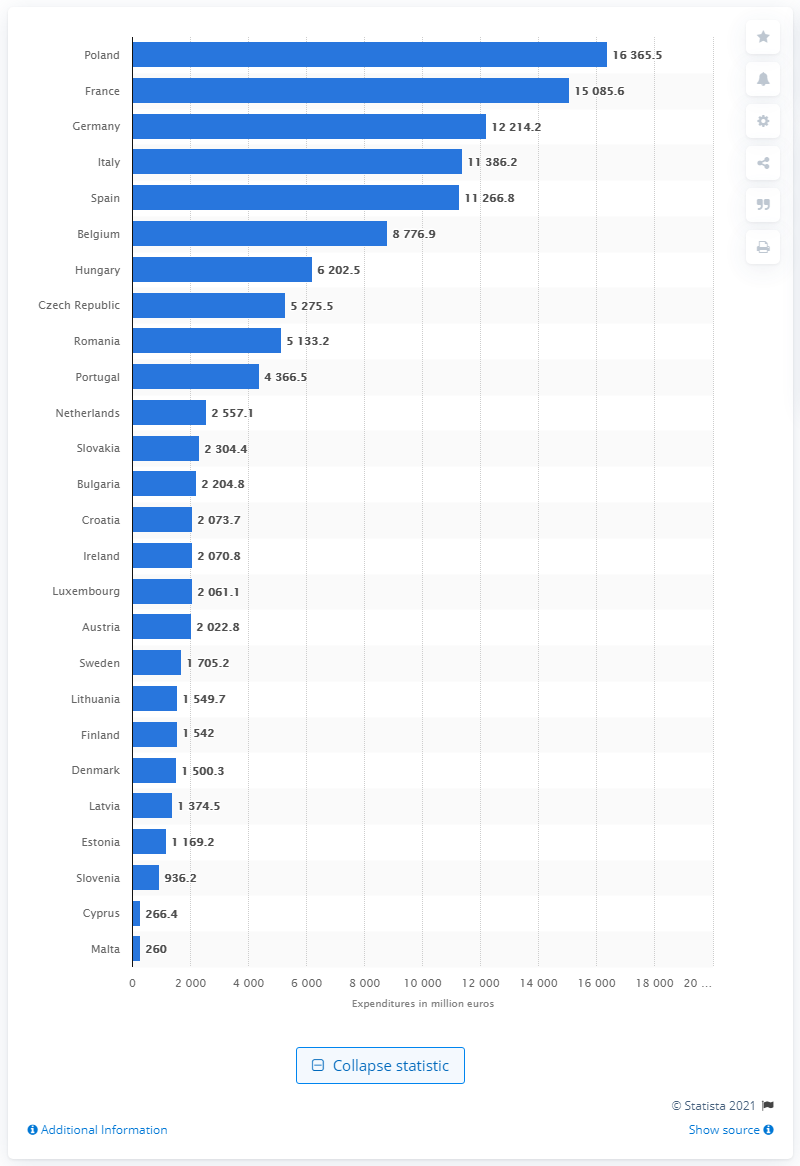Outline some significant characteristics in this image. In 2019, Poland received 16,365.5 euros from the EU budget. 